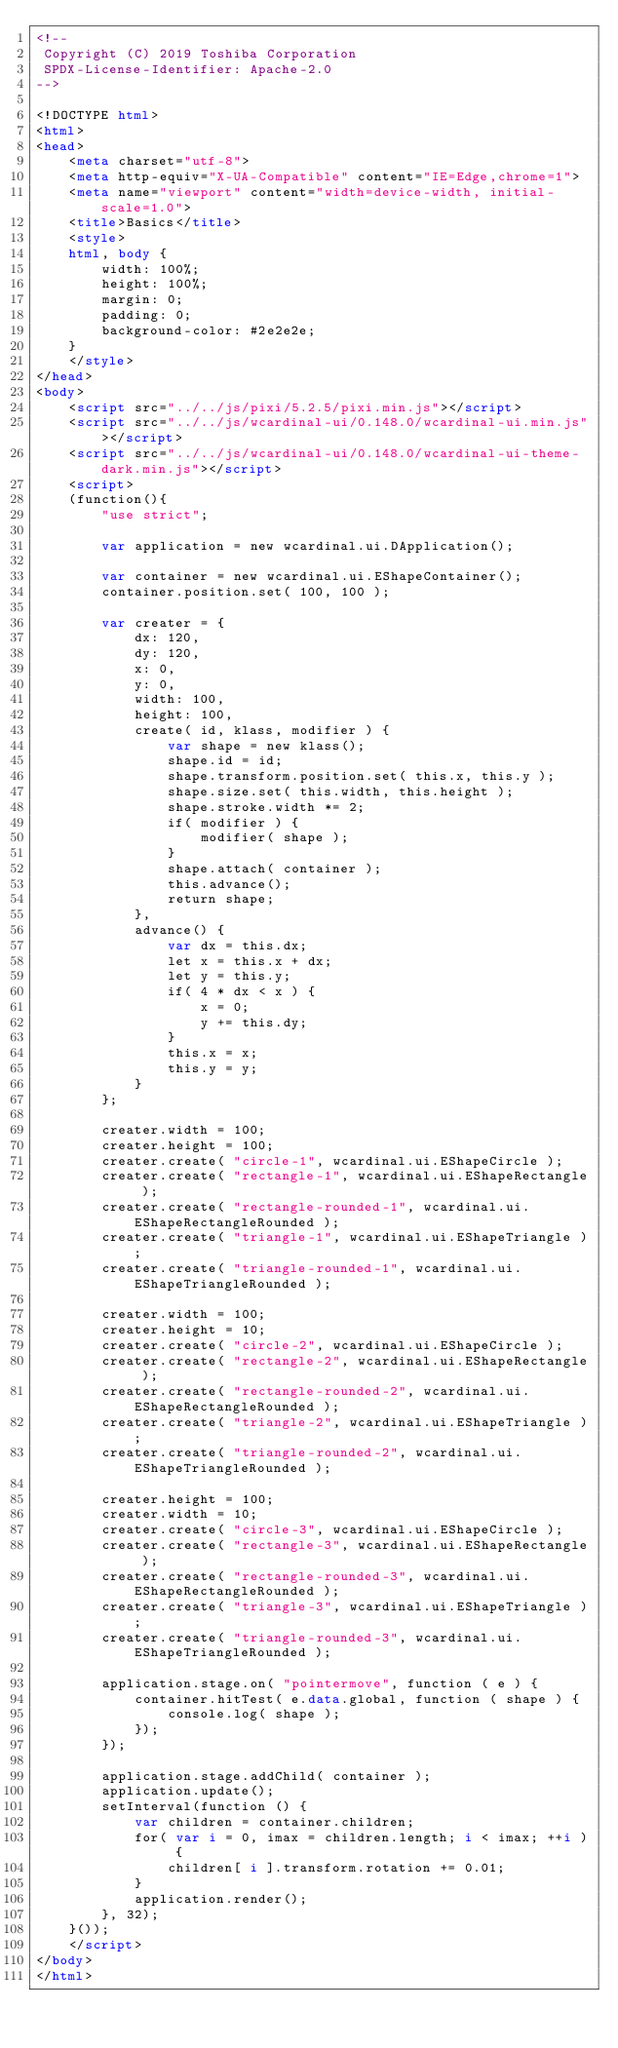Convert code to text. <code><loc_0><loc_0><loc_500><loc_500><_HTML_><!--
 Copyright (C) 2019 Toshiba Corporation
 SPDX-License-Identifier: Apache-2.0
-->

<!DOCTYPE html>
<html>
<head>
	<meta charset="utf-8">
	<meta http-equiv="X-UA-Compatible" content="IE=Edge,chrome=1">
	<meta name="viewport" content="width=device-width, initial-scale=1.0">
	<title>Basics</title>
	<style>
	html, body {
		width: 100%;
		height: 100%;
		margin: 0;
		padding: 0;
		background-color: #2e2e2e;
	}
	</style>
</head>
<body>
	<script src="../../js/pixi/5.2.5/pixi.min.js"></script>
	<script src="../../js/wcardinal-ui/0.148.0/wcardinal-ui.min.js"></script>
	<script src="../../js/wcardinal-ui/0.148.0/wcardinal-ui-theme-dark.min.js"></script>
	<script>
	(function(){
		"use strict";

		var application = new wcardinal.ui.DApplication();

		var container = new wcardinal.ui.EShapeContainer();
		container.position.set( 100, 100 );

		var creater = {
			dx: 120,
			dy: 120,
			x: 0,
			y: 0,
			width: 100,
			height: 100,
			create( id, klass, modifier ) {
				var shape = new klass();
				shape.id = id;
				shape.transform.position.set( this.x, this.y );
				shape.size.set( this.width, this.height );
				shape.stroke.width *= 2;
				if( modifier ) {
					modifier( shape );
				}
				shape.attach( container );
				this.advance();
				return shape;
			},
			advance() {
				var dx = this.dx;
				let x = this.x + dx;
				let y = this.y;
				if( 4 * dx < x ) {
					x = 0;
					y += this.dy;
				}
				this.x = x;
				this.y = y;
			}
		};

		creater.width = 100;
		creater.height = 100;
		creater.create( "circle-1", wcardinal.ui.EShapeCircle );
		creater.create( "rectangle-1", wcardinal.ui.EShapeRectangle );
		creater.create( "rectangle-rounded-1", wcardinal.ui.EShapeRectangleRounded );
		creater.create( "triangle-1", wcardinal.ui.EShapeTriangle );
		creater.create( "triangle-rounded-1", wcardinal.ui.EShapeTriangleRounded );

		creater.width = 100;
		creater.height = 10;
		creater.create( "circle-2", wcardinal.ui.EShapeCircle );
		creater.create( "rectangle-2", wcardinal.ui.EShapeRectangle );
		creater.create( "rectangle-rounded-2", wcardinal.ui.EShapeRectangleRounded );
		creater.create( "triangle-2", wcardinal.ui.EShapeTriangle );
		creater.create( "triangle-rounded-2", wcardinal.ui.EShapeTriangleRounded );

		creater.height = 100;
		creater.width = 10;
		creater.create( "circle-3", wcardinal.ui.EShapeCircle );
		creater.create( "rectangle-3", wcardinal.ui.EShapeRectangle );
		creater.create( "rectangle-rounded-3", wcardinal.ui.EShapeRectangleRounded );
		creater.create( "triangle-3", wcardinal.ui.EShapeTriangle );
		creater.create( "triangle-rounded-3", wcardinal.ui.EShapeTriangleRounded );

		application.stage.on( "pointermove", function ( e ) {
			container.hitTest( e.data.global, function ( shape ) {
				console.log( shape );
			});
		});

		application.stage.addChild( container );
		application.update();
		setInterval(function () {
			var children = container.children;
			for( var i = 0, imax = children.length; i < imax; ++i ) {
				children[ i ].transform.rotation += 0.01;
			}
			application.render();
		}, 32);
	}());
	</script>
</body>
</html>
</code> 